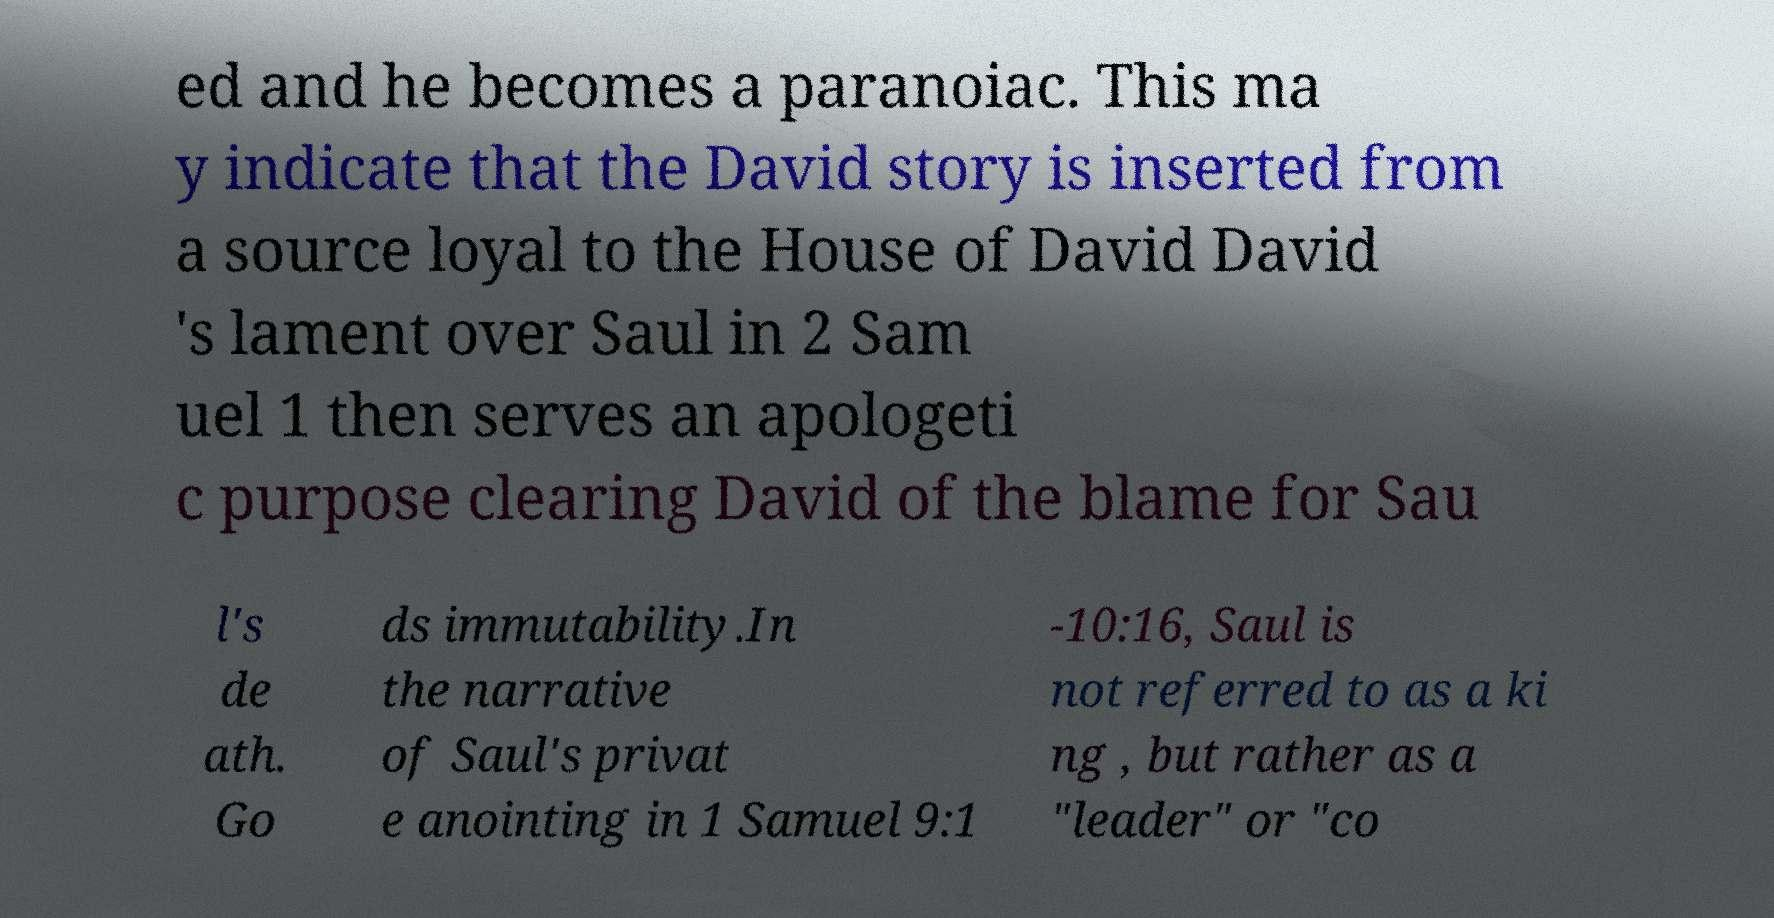Please read and relay the text visible in this image. What does it say? ed and he becomes a paranoiac. This ma y indicate that the David story is inserted from a source loyal to the House of David David 's lament over Saul in 2 Sam uel 1 then serves an apologeti c purpose clearing David of the blame for Sau l's de ath. Go ds immutability.In the narrative of Saul's privat e anointing in 1 Samuel 9:1 -10:16, Saul is not referred to as a ki ng , but rather as a "leader" or "co 